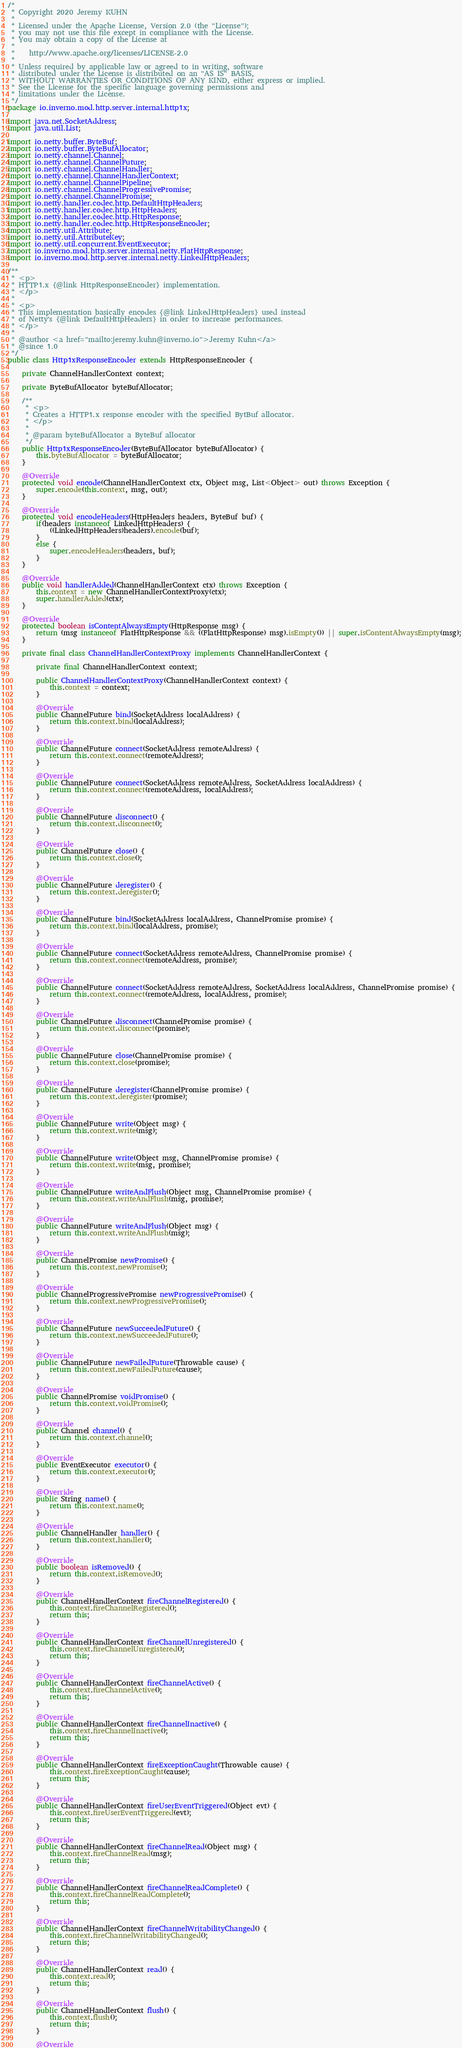Convert code to text. <code><loc_0><loc_0><loc_500><loc_500><_Java_>/*
 * Copyright 2020 Jeremy KUHN
 *
 * Licensed under the Apache License, Version 2.0 (the "License");
 * you may not use this file except in compliance with the License.
 * You may obtain a copy of the License at
 *
 *    http://www.apache.org/licenses/LICENSE-2.0
 *
 * Unless required by applicable law or agreed to in writing, software
 * distributed under the License is distributed on an "AS IS" BASIS,
 * WITHOUT WARRANTIES OR CONDITIONS OF ANY KIND, either express or implied.
 * See the License for the specific language governing permissions and
 * limitations under the License.
 */
package io.inverno.mod.http.server.internal.http1x;

import java.net.SocketAddress;
import java.util.List;

import io.netty.buffer.ByteBuf;
import io.netty.buffer.ByteBufAllocator;
import io.netty.channel.Channel;
import io.netty.channel.ChannelFuture;
import io.netty.channel.ChannelHandler;
import io.netty.channel.ChannelHandlerContext;
import io.netty.channel.ChannelPipeline;
import io.netty.channel.ChannelProgressivePromise;
import io.netty.channel.ChannelPromise;
import io.netty.handler.codec.http.DefaultHttpHeaders;
import io.netty.handler.codec.http.HttpHeaders;
import io.netty.handler.codec.http.HttpResponse;
import io.netty.handler.codec.http.HttpResponseEncoder;
import io.netty.util.Attribute;
import io.netty.util.AttributeKey;
import io.netty.util.concurrent.EventExecutor;
import io.inverno.mod.http.server.internal.netty.FlatHttpResponse;
import io.inverno.mod.http.server.internal.netty.LinkedHttpHeaders;

/**
 * <p>
 * HTTP1.x {@link HttpResponseEncoder} implementation.
 * </p>
 * 
 * <p>
 * This implementation basically encodes {@link LinkedHttpHeaders} used instead
 * of Netty's {@link DefaultHttpHeaders} in order to increase performances.
 * </p>
 * 
 * @author <a href="mailto:jeremy.kuhn@inverno.io">Jeremy Kuhn</a>
 * @since 1.0
 */
public class Http1xResponseEncoder extends HttpResponseEncoder {

	private ChannelHandlerContext context;
	
	private ByteBufAllocator byteBufAllocator;
	
	/**
	 * <p>
	 * Creates a HTTP1.x response encoder with the specified BytBuf allocator.
	 * </p>
	 * 
	 * @param byteBufAllocator a ByteBuf allocator
	 */
	public Http1xResponseEncoder(ByteBufAllocator byteBufAllocator) {
		this.byteBufAllocator = byteBufAllocator;
	}

	@Override
	protected void encode(ChannelHandlerContext ctx, Object msg, List<Object> out) throws Exception {
		super.encode(this.context, msg, out);
	}

	@Override
	protected void encodeHeaders(HttpHeaders headers, ByteBuf buf) {
		if(headers instanceof LinkedHttpHeaders) {
			((LinkedHttpHeaders)headers).encode(buf);
		}
		else {
			super.encodeHeaders(headers, buf);
		}
	}

	@Override
	public void handlerAdded(ChannelHandlerContext ctx) throws Exception {
		this.context = new ChannelHandlerContextProxy(ctx);
		super.handlerAdded(ctx);
	}

	@Override
	protected boolean isContentAlwaysEmpty(HttpResponse msg) {
		return (msg instanceof FlatHttpResponse && ((FlatHttpResponse) msg).isEmpty()) || super.isContentAlwaysEmpty(msg);
	}

	private final class ChannelHandlerContextProxy implements ChannelHandlerContext {

		private final ChannelHandlerContext context;
		
		public ChannelHandlerContextProxy(ChannelHandlerContext context) {
			this.context = context;
		}
		
		@Override
		public ChannelFuture bind(SocketAddress localAddress) {
			return this.context.bind(localAddress);
		}

		@Override
		public ChannelFuture connect(SocketAddress remoteAddress) {
			return this.context.connect(remoteAddress);
		}

		@Override
		public ChannelFuture connect(SocketAddress remoteAddress, SocketAddress localAddress) {
			return this.context.connect(remoteAddress, localAddress);
		}

		@Override
		public ChannelFuture disconnect() {
			return this.context.disconnect();
		}

		@Override
		public ChannelFuture close() {
			return this.context.close();
		}

		@Override
		public ChannelFuture deregister() {
			return this.context.deregister();
		}

		@Override
		public ChannelFuture bind(SocketAddress localAddress, ChannelPromise promise) {
			return this.context.bind(localAddress, promise);
		}

		@Override
		public ChannelFuture connect(SocketAddress remoteAddress, ChannelPromise promise) {
			return this.context.connect(remoteAddress, promise);
		}

		@Override
		public ChannelFuture connect(SocketAddress remoteAddress, SocketAddress localAddress, ChannelPromise promise) {
			return this.context.connect(remoteAddress, localAddress, promise);
		}

		@Override
		public ChannelFuture disconnect(ChannelPromise promise) {
			return this.context.disconnect(promise);
		}

		@Override
		public ChannelFuture close(ChannelPromise promise) {
			return this.context.close(promise);
		}

		@Override
		public ChannelFuture deregister(ChannelPromise promise) {
			return this.context.deregister(promise);
		}

		@Override
		public ChannelFuture write(Object msg) {
			return this.context.write(msg);
		}

		@Override
		public ChannelFuture write(Object msg, ChannelPromise promise) {
			return this.context.write(msg, promise);
		}

		@Override
		public ChannelFuture writeAndFlush(Object msg, ChannelPromise promise) {
			return this.context.writeAndFlush(msg, promise);
		}

		@Override
		public ChannelFuture writeAndFlush(Object msg) {
			return this.context.writeAndFlush(msg);
		}

		@Override
		public ChannelPromise newPromise() {
			return this.context.newPromise();
		}

		@Override
		public ChannelProgressivePromise newProgressivePromise() {
			return this.context.newProgressivePromise();
		}

		@Override
		public ChannelFuture newSucceededFuture() {
			return this.context.newSucceededFuture();
		}

		@Override
		public ChannelFuture newFailedFuture(Throwable cause) {
			return this.context.newFailedFuture(cause);
		}

		@Override
		public ChannelPromise voidPromise() {
			return this.context.voidPromise();
		}

		@Override
		public Channel channel() {
			return this.context.channel();
		}

		@Override
		public EventExecutor executor() {
			return this.context.executor();
		}

		@Override
		public String name() {
			return this.context.name();
		}

		@Override
		public ChannelHandler handler() {
			return this.context.handler();
		}

		@Override
		public boolean isRemoved() {
			return this.context.isRemoved();
		}

		@Override
		public ChannelHandlerContext fireChannelRegistered() {
			this.context.fireChannelRegistered();
			return this;
		}

		@Override
		public ChannelHandlerContext fireChannelUnregistered() {
			this.context.fireChannelUnregistered();
			return this;
		}

		@Override
		public ChannelHandlerContext fireChannelActive() {
			this.context.fireChannelActive();
			return this;
		}

		@Override
		public ChannelHandlerContext fireChannelInactive() {
			this.context.fireChannelInactive();
			return this;
		}

		@Override
		public ChannelHandlerContext fireExceptionCaught(Throwable cause) {
			this.context.fireExceptionCaught(cause);
			return this;
		}

		@Override
		public ChannelHandlerContext fireUserEventTriggered(Object evt) {
			this.context.fireUserEventTriggered(evt);
			return this;
		}

		@Override
		public ChannelHandlerContext fireChannelRead(Object msg) {
			this.context.fireChannelRead(msg);
			return this;
		}

		@Override
		public ChannelHandlerContext fireChannelReadComplete() {
			this.context.fireChannelReadComplete();
			return this;
		}

		@Override
		public ChannelHandlerContext fireChannelWritabilityChanged() {
			this.context.fireChannelWritabilityChanged();
			return this;
		}

		@Override
		public ChannelHandlerContext read() {
			this.context.read();
			return this;
		}

		@Override
		public ChannelHandlerContext flush() {
			this.context.flush();
			return this;
		}

		@Override</code> 